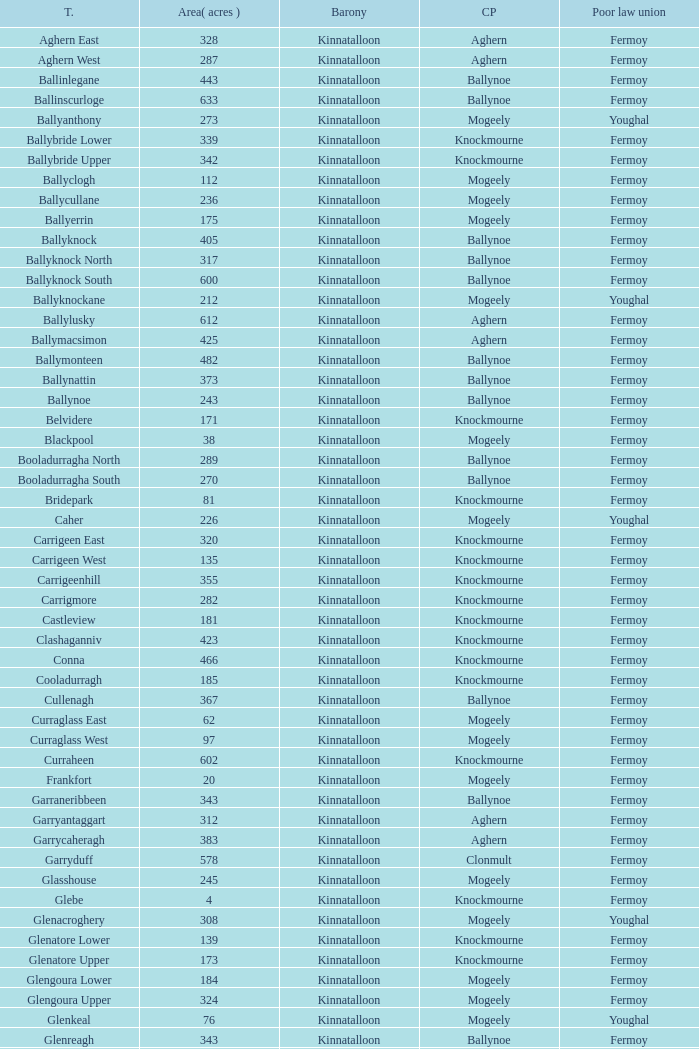Name  the townland for fermoy and ballynoe Ballinlegane, Ballinscurloge, Ballyknock, Ballyknock North, Ballyknock South, Ballymonteen, Ballynattin, Ballynoe, Booladurragha North, Booladurragha South, Cullenagh, Garraneribbeen, Glenreagh, Glentane, Killasseragh, Kilphillibeen, Knockakeo, Longueville North, Longueville South, Rathdrum, Shanaboola. Parse the table in full. {'header': ['T.', 'Area( acres )', 'Barony', 'CP', 'Poor law union'], 'rows': [['Aghern East', '328', 'Kinnatalloon', 'Aghern', 'Fermoy'], ['Aghern West', '287', 'Kinnatalloon', 'Aghern', 'Fermoy'], ['Ballinlegane', '443', 'Kinnatalloon', 'Ballynoe', 'Fermoy'], ['Ballinscurloge', '633', 'Kinnatalloon', 'Ballynoe', 'Fermoy'], ['Ballyanthony', '273', 'Kinnatalloon', 'Mogeely', 'Youghal'], ['Ballybride Lower', '339', 'Kinnatalloon', 'Knockmourne', 'Fermoy'], ['Ballybride Upper', '342', 'Kinnatalloon', 'Knockmourne', 'Fermoy'], ['Ballyclogh', '112', 'Kinnatalloon', 'Mogeely', 'Fermoy'], ['Ballycullane', '236', 'Kinnatalloon', 'Mogeely', 'Fermoy'], ['Ballyerrin', '175', 'Kinnatalloon', 'Mogeely', 'Fermoy'], ['Ballyknock', '405', 'Kinnatalloon', 'Ballynoe', 'Fermoy'], ['Ballyknock North', '317', 'Kinnatalloon', 'Ballynoe', 'Fermoy'], ['Ballyknock South', '600', 'Kinnatalloon', 'Ballynoe', 'Fermoy'], ['Ballyknockane', '212', 'Kinnatalloon', 'Mogeely', 'Youghal'], ['Ballylusky', '612', 'Kinnatalloon', 'Aghern', 'Fermoy'], ['Ballymacsimon', '425', 'Kinnatalloon', 'Aghern', 'Fermoy'], ['Ballymonteen', '482', 'Kinnatalloon', 'Ballynoe', 'Fermoy'], ['Ballynattin', '373', 'Kinnatalloon', 'Ballynoe', 'Fermoy'], ['Ballynoe', '243', 'Kinnatalloon', 'Ballynoe', 'Fermoy'], ['Belvidere', '171', 'Kinnatalloon', 'Knockmourne', 'Fermoy'], ['Blackpool', '38', 'Kinnatalloon', 'Mogeely', 'Fermoy'], ['Booladurragha North', '289', 'Kinnatalloon', 'Ballynoe', 'Fermoy'], ['Booladurragha South', '270', 'Kinnatalloon', 'Ballynoe', 'Fermoy'], ['Bridepark', '81', 'Kinnatalloon', 'Knockmourne', 'Fermoy'], ['Caher', '226', 'Kinnatalloon', 'Mogeely', 'Youghal'], ['Carrigeen East', '320', 'Kinnatalloon', 'Knockmourne', 'Fermoy'], ['Carrigeen West', '135', 'Kinnatalloon', 'Knockmourne', 'Fermoy'], ['Carrigeenhill', '355', 'Kinnatalloon', 'Knockmourne', 'Fermoy'], ['Carrigmore', '282', 'Kinnatalloon', 'Knockmourne', 'Fermoy'], ['Castleview', '181', 'Kinnatalloon', 'Knockmourne', 'Fermoy'], ['Clashaganniv', '423', 'Kinnatalloon', 'Knockmourne', 'Fermoy'], ['Conna', '466', 'Kinnatalloon', 'Knockmourne', 'Fermoy'], ['Cooladurragh', '185', 'Kinnatalloon', 'Knockmourne', 'Fermoy'], ['Cullenagh', '367', 'Kinnatalloon', 'Ballynoe', 'Fermoy'], ['Curraglass East', '62', 'Kinnatalloon', 'Mogeely', 'Fermoy'], ['Curraglass West', '97', 'Kinnatalloon', 'Mogeely', 'Fermoy'], ['Curraheen', '602', 'Kinnatalloon', 'Knockmourne', 'Fermoy'], ['Frankfort', '20', 'Kinnatalloon', 'Mogeely', 'Fermoy'], ['Garraneribbeen', '343', 'Kinnatalloon', 'Ballynoe', 'Fermoy'], ['Garryantaggart', '312', 'Kinnatalloon', 'Aghern', 'Fermoy'], ['Garrycaheragh', '383', 'Kinnatalloon', 'Aghern', 'Fermoy'], ['Garryduff', '578', 'Kinnatalloon', 'Clonmult', 'Fermoy'], ['Glasshouse', '245', 'Kinnatalloon', 'Mogeely', 'Fermoy'], ['Glebe', '4', 'Kinnatalloon', 'Knockmourne', 'Fermoy'], ['Glenacroghery', '308', 'Kinnatalloon', 'Mogeely', 'Youghal'], ['Glenatore Lower', '139', 'Kinnatalloon', 'Knockmourne', 'Fermoy'], ['Glenatore Upper', '173', 'Kinnatalloon', 'Knockmourne', 'Fermoy'], ['Glengoura Lower', '184', 'Kinnatalloon', 'Mogeely', 'Fermoy'], ['Glengoura Upper', '324', 'Kinnatalloon', 'Mogeely', 'Fermoy'], ['Glenkeal', '76', 'Kinnatalloon', 'Mogeely', 'Youghal'], ['Glenreagh', '343', 'Kinnatalloon', 'Ballynoe', 'Fermoy'], ['Glentane', '274', 'Kinnatalloon', 'Ballynoe', 'Fermoy'], ['Glentrasna', '284', 'Kinnatalloon', 'Aghern', 'Fermoy'], ['Glentrasna North', '219', 'Kinnatalloon', 'Aghern', 'Fermoy'], ['Glentrasna South', '220', 'Kinnatalloon', 'Aghern', 'Fermoy'], ['Gortnafira', '78', 'Kinnatalloon', 'Mogeely', 'Fermoy'], ['Inchyallagh', '8', 'Kinnatalloon', 'Mogeely', 'Fermoy'], ['Kilclare Lower', '109', 'Kinnatalloon', 'Knockmourne', 'Fermoy'], ['Kilclare Upper', '493', 'Kinnatalloon', 'Knockmourne', 'Fermoy'], ['Kilcronat', '516', 'Kinnatalloon', 'Mogeely', 'Youghal'], ['Kilcronatmountain', '385', 'Kinnatalloon', 'Mogeely', 'Youghal'], ['Killasseragh', '340', 'Kinnatalloon', 'Ballynoe', 'Fermoy'], ['Killavarilly', '372', 'Kinnatalloon', 'Knockmourne', 'Fermoy'], ['Kilmacow', '316', 'Kinnatalloon', 'Mogeely', 'Fermoy'], ['Kilnafurrery', '256', 'Kinnatalloon', 'Mogeely', 'Youghal'], ['Kilphillibeen', '535', 'Kinnatalloon', 'Ballynoe', 'Fermoy'], ['Knockacool', '404', 'Kinnatalloon', 'Mogeely', 'Youghal'], ['Knockakeo', '296', 'Kinnatalloon', 'Ballynoe', 'Fermoy'], ['Knockanarrig', '215', 'Kinnatalloon', 'Mogeely', 'Youghal'], ['Knockastickane', '164', 'Kinnatalloon', 'Knockmourne', 'Fermoy'], ['Knocknagapple', '293', 'Kinnatalloon', 'Aghern', 'Fermoy'], ['Lackbrack', '84', 'Kinnatalloon', 'Mogeely', 'Fermoy'], ['Lacken', '262', 'Kinnatalloon', 'Mogeely', 'Youghal'], ['Lackenbehy', '101', 'Kinnatalloon', 'Mogeely', 'Fermoy'], ['Limekilnclose', '41', 'Kinnatalloon', 'Mogeely', 'Lismore'], ['Lisnabrin Lower', '114', 'Kinnatalloon', 'Mogeely', 'Fermoy'], ['Lisnabrin North', '217', 'Kinnatalloon', 'Mogeely', 'Fermoy'], ['Lisnabrin South', '180', 'Kinnatalloon', 'Mogeely', 'Fermoy'], ['Lisnabrinlodge', '28', 'Kinnatalloon', 'Mogeely', 'Fermoy'], ['Littlegrace', '50', 'Kinnatalloon', 'Knockmourne', 'Lismore'], ['Longueville North', '355', 'Kinnatalloon', 'Ballynoe', 'Fermoy'], ['Longueville South', '271', 'Kinnatalloon', 'Ballynoe', 'Fermoy'], ['Lyre', '160', 'Kinnatalloon', 'Mogeely', 'Youghal'], ['Lyre Mountain', '360', 'Kinnatalloon', 'Mogeely', 'Youghal'], ['Mogeely Lower', '304', 'Kinnatalloon', 'Mogeely', 'Fermoy'], ['Mogeely Upper', '247', 'Kinnatalloon', 'Mogeely', 'Fermoy'], ['Monagown', '491', 'Kinnatalloon', 'Knockmourne', 'Fermoy'], ['Monaloo', '458', 'Kinnatalloon', 'Mogeely', 'Youghal'], ['Mountprospect', '102', 'Kinnatalloon', 'Mogeely', 'Fermoy'], ['Park', '119', 'Kinnatalloon', 'Aghern', 'Fermoy'], ['Poundfields', '15', 'Kinnatalloon', 'Mogeely', 'Fermoy'], ['Rathdrum', '336', 'Kinnatalloon', 'Ballynoe', 'Fermoy'], ['Rathdrum', '339', 'Kinnatalloon', 'Britway', 'Fermoy'], ['Reanduff', '318', 'Kinnatalloon', 'Mogeely', 'Youghal'], ['Rearour North', '208', 'Kinnatalloon', 'Mogeely', 'Youghal'], ['Rearour South', '223', 'Kinnatalloon', 'Mogeely', 'Youghal'], ['Rosybower', '105', 'Kinnatalloon', 'Mogeely', 'Fermoy'], ['Sandyhill', '263', 'Kinnatalloon', 'Mogeely', 'Youghal'], ['Shanaboola', '190', 'Kinnatalloon', 'Ballynoe', 'Fermoy'], ['Shanakill Lower', '244', 'Kinnatalloon', 'Mogeely', 'Fermoy'], ['Shanakill Upper', '244', 'Kinnatalloon', 'Mogeely', 'Fermoy'], ['Slieveadoctor', '260', 'Kinnatalloon', 'Mogeely', 'Fermoy'], ['Templevally', '330', 'Kinnatalloon', 'Mogeely', 'Fermoy'], ['Vinepark', '7', 'Kinnatalloon', 'Mogeely', 'Fermoy']]} 